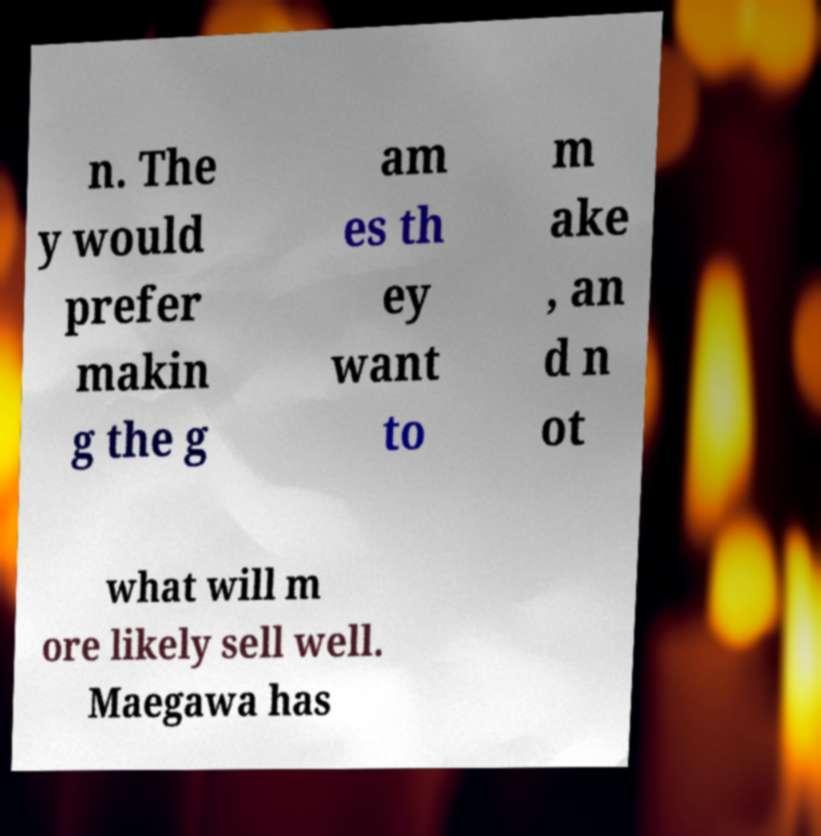Please identify and transcribe the text found in this image. n. The y would prefer makin g the g am es th ey want to m ake , an d n ot what will m ore likely sell well. Maegawa has 